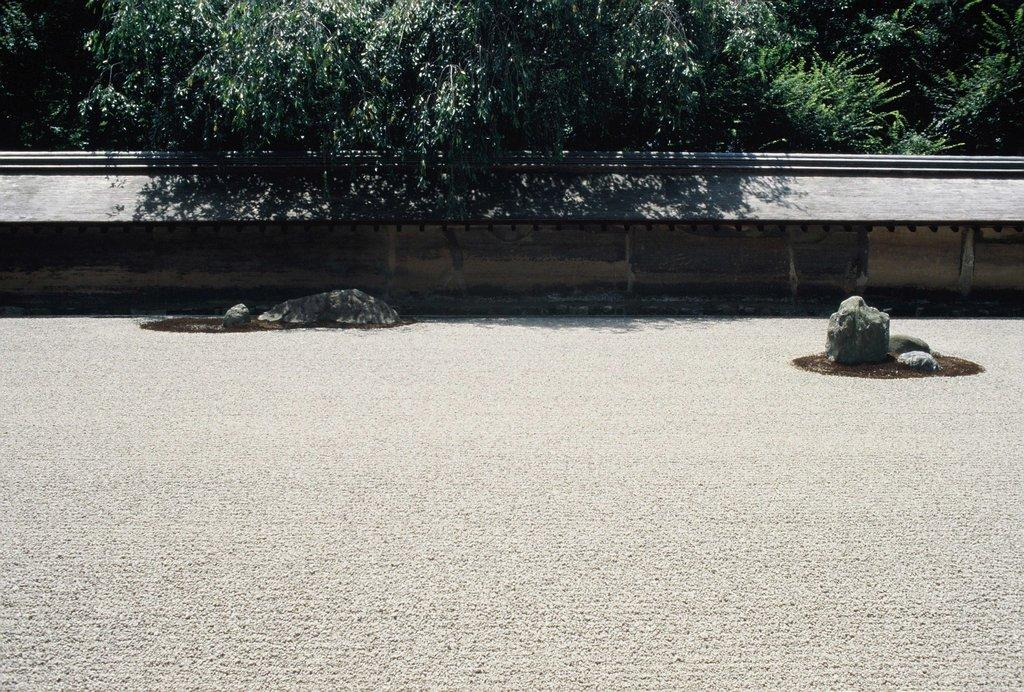What type of natural feature can be seen on the land in the image? There are rocks on the land in the image. What man-made structure is present in the image? There is a wall in the image. What type of vegetation is visible in the background of the image? There are trees visible in the background of the image. What type of snack is being shared among the trees in the image? There is no snack, such as popcorn, present in the image; it features rocks, a wall, and trees. 